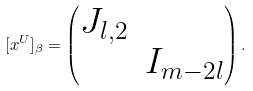Convert formula to latex. <formula><loc_0><loc_0><loc_500><loc_500>[ x ^ { U } ] _ { \beta } = \begin{pmatrix} J _ { l , 2 } \\ & I _ { m - 2 l } \end{pmatrix} .</formula> 